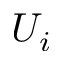<formula> <loc_0><loc_0><loc_500><loc_500>U _ { i }</formula> 